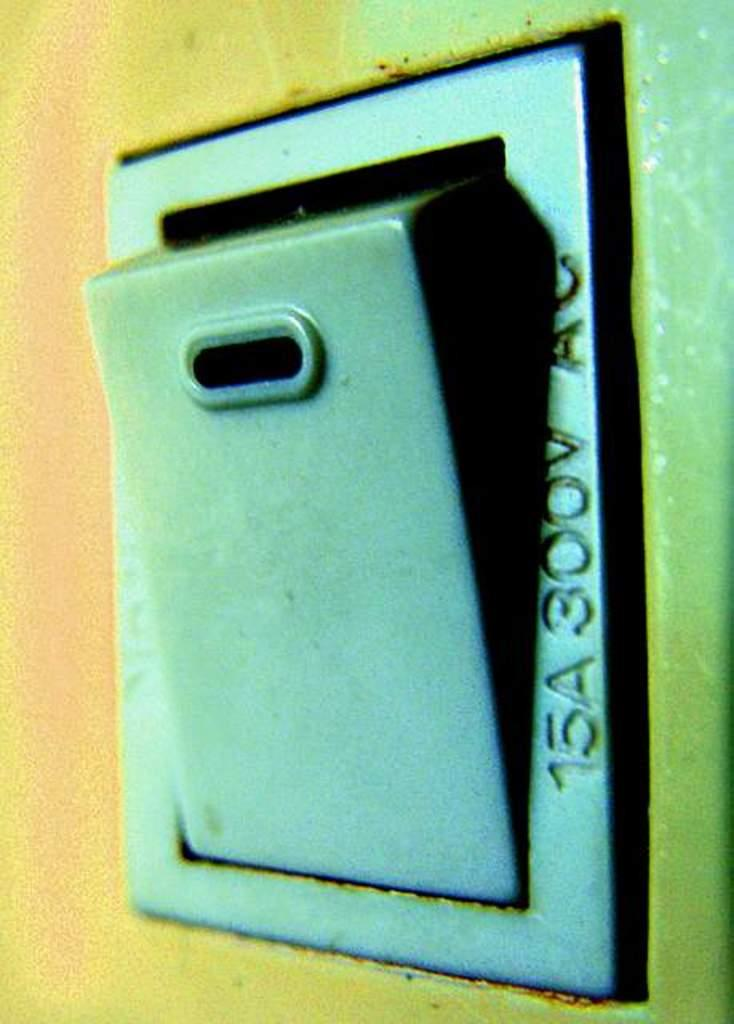<image>
Relay a brief, clear account of the picture shown. A box is shown with 15A on the side. 